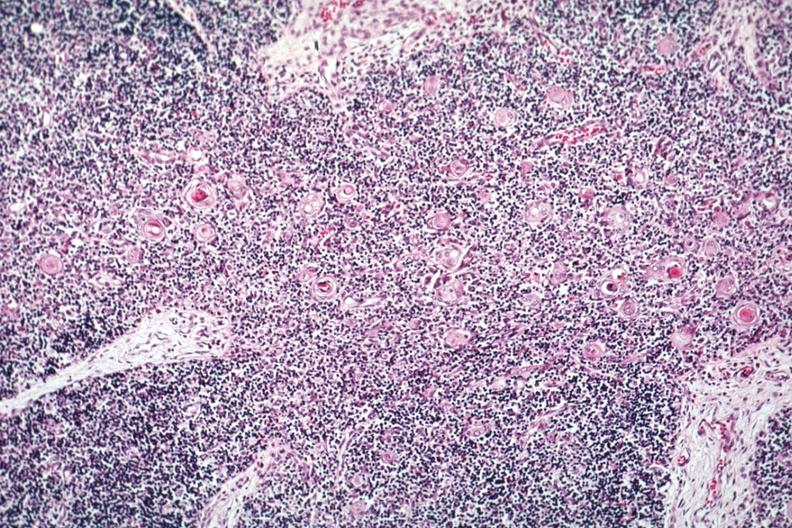s thymus present?
Answer the question using a single word or phrase. Yes 